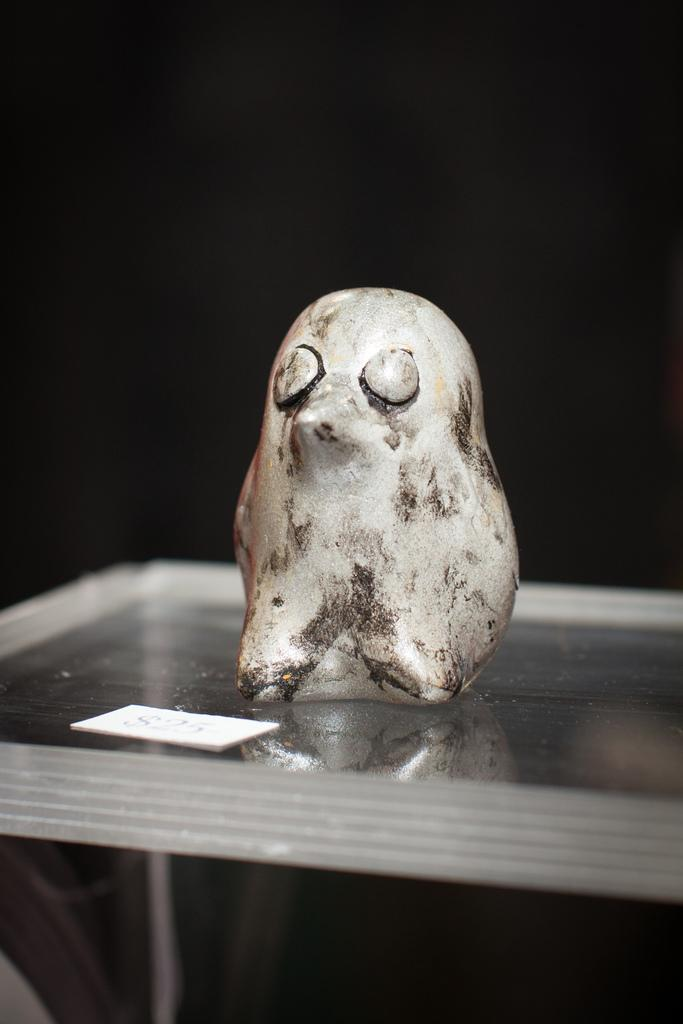What is the main subject of the image? The main subject of the image is a statue of a bird. Where is the statue located? The statue is on a glass table. Is there any text visible in the image? Yes, there is a label with text on the table. What type of party is happening in the image? There is no party happening in the image; it features a statue of a bird on a glass table with a label. 